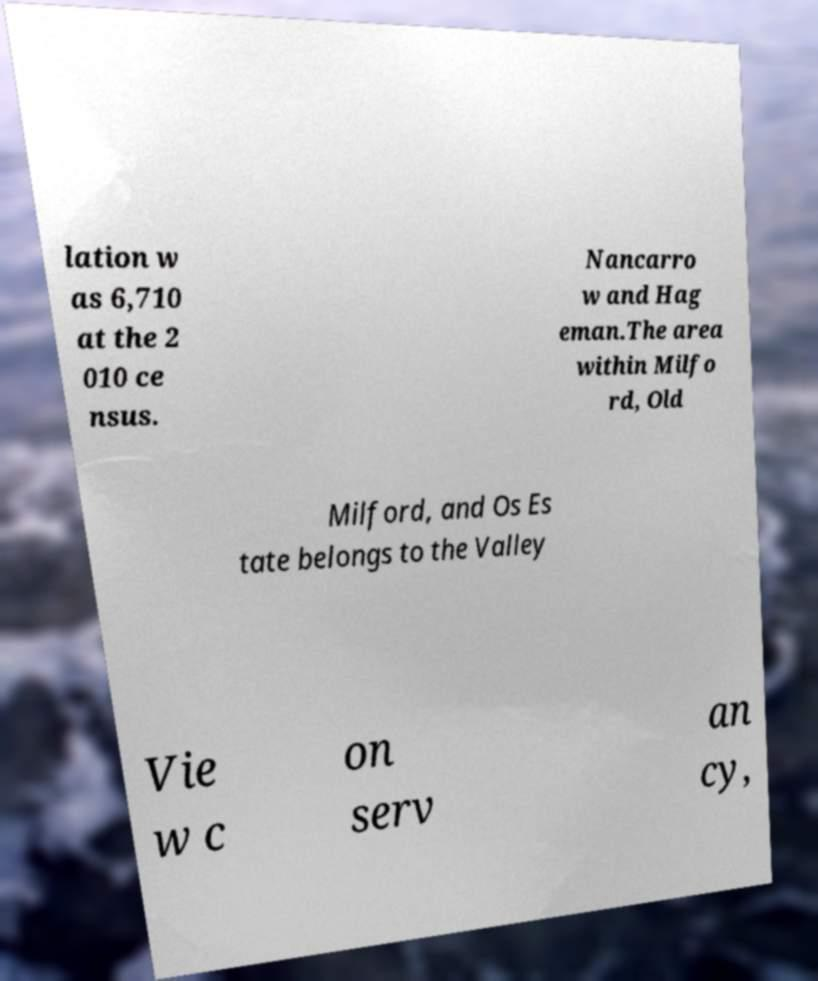Please read and relay the text visible in this image. What does it say? lation w as 6,710 at the 2 010 ce nsus. Nancarro w and Hag eman.The area within Milfo rd, Old Milford, and Os Es tate belongs to the Valley Vie w c on serv an cy, 